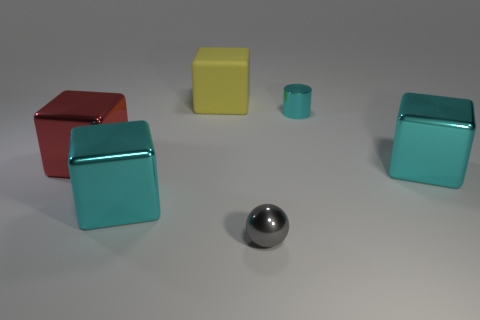The gray object that is made of the same material as the cylinder is what size? The gray object is a sphere, and it appears to be small in size, comparable to the smaller turquoise cylinder but significantly smaller than the other objects. 